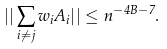<formula> <loc_0><loc_0><loc_500><loc_500>| | \sum _ { i \neq j } w _ { i } A _ { i } | | \leq n ^ { - 4 B - 7 } .</formula> 